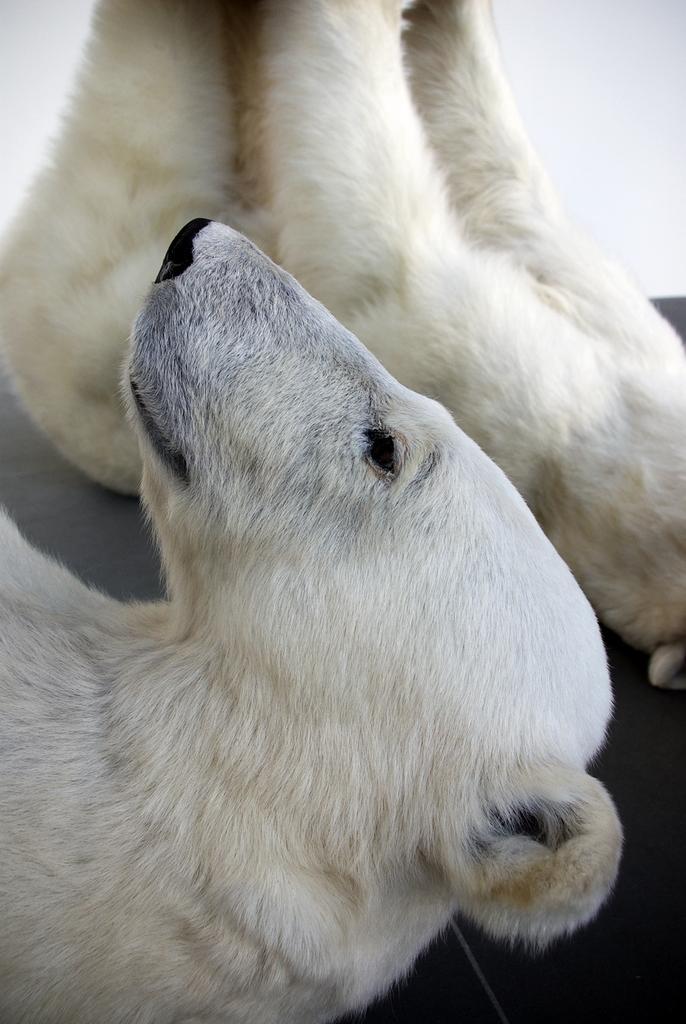Can you describe this image briefly? In this image there are two truncated polar bears on the surface, the background of the image is white in color. 